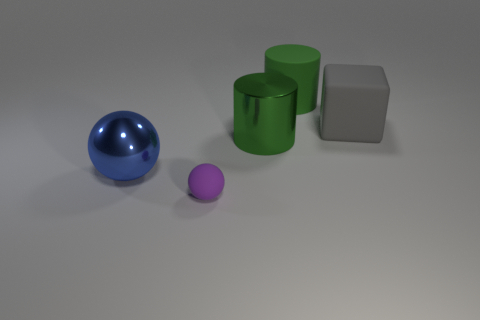Is the shape of the small matte object the same as the blue metallic object?
Your response must be concise. Yes. Is there any other thing that has the same shape as the big blue object?
Your response must be concise. Yes. There is a large cylinder right of the big green shiny cylinder; is it the same color as the metallic object to the right of the small purple object?
Give a very brief answer. Yes. Is the number of small purple spheres that are left of the small purple object less than the number of spheres in front of the large metal sphere?
Provide a succinct answer. Yes. What shape is the big shiny object left of the purple sphere?
Your answer should be very brief. Sphere. What material is the other cylinder that is the same color as the large rubber cylinder?
Offer a very short reply. Metal. How many other things are made of the same material as the large ball?
Make the answer very short. 1. There is a gray thing; is its shape the same as the large green object behind the rubber block?
Give a very brief answer. No. There is a large green object that is the same material as the big blue ball; what is its shape?
Ensure brevity in your answer.  Cylinder. Is the number of green rubber objects that are on the right side of the purple thing greater than the number of big green matte cylinders to the left of the green matte object?
Offer a terse response. Yes. 